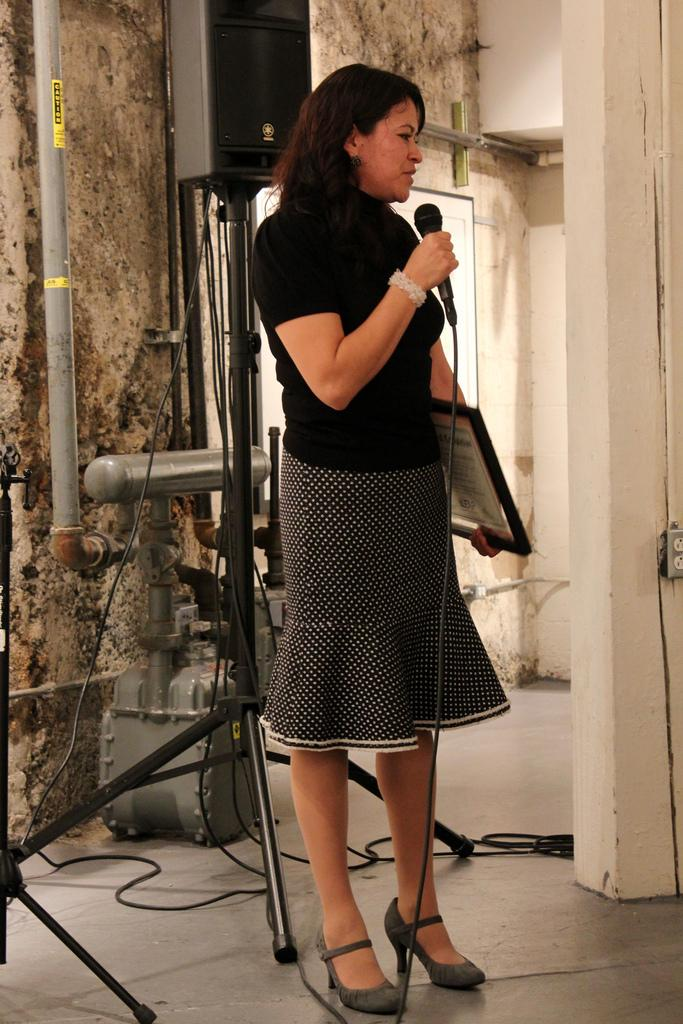What is the woman in the image doing? The woman is talking on a microphone. What is the woman holding in her hand? The woman is holding a frame in her hand. What type of surface is visible beneath the woman? There is a floor in the image. What is visible behind the woman? There is a wall in the image. What type of comfort can be seen in the image? There is no specific comfort item or feature present in the image. 